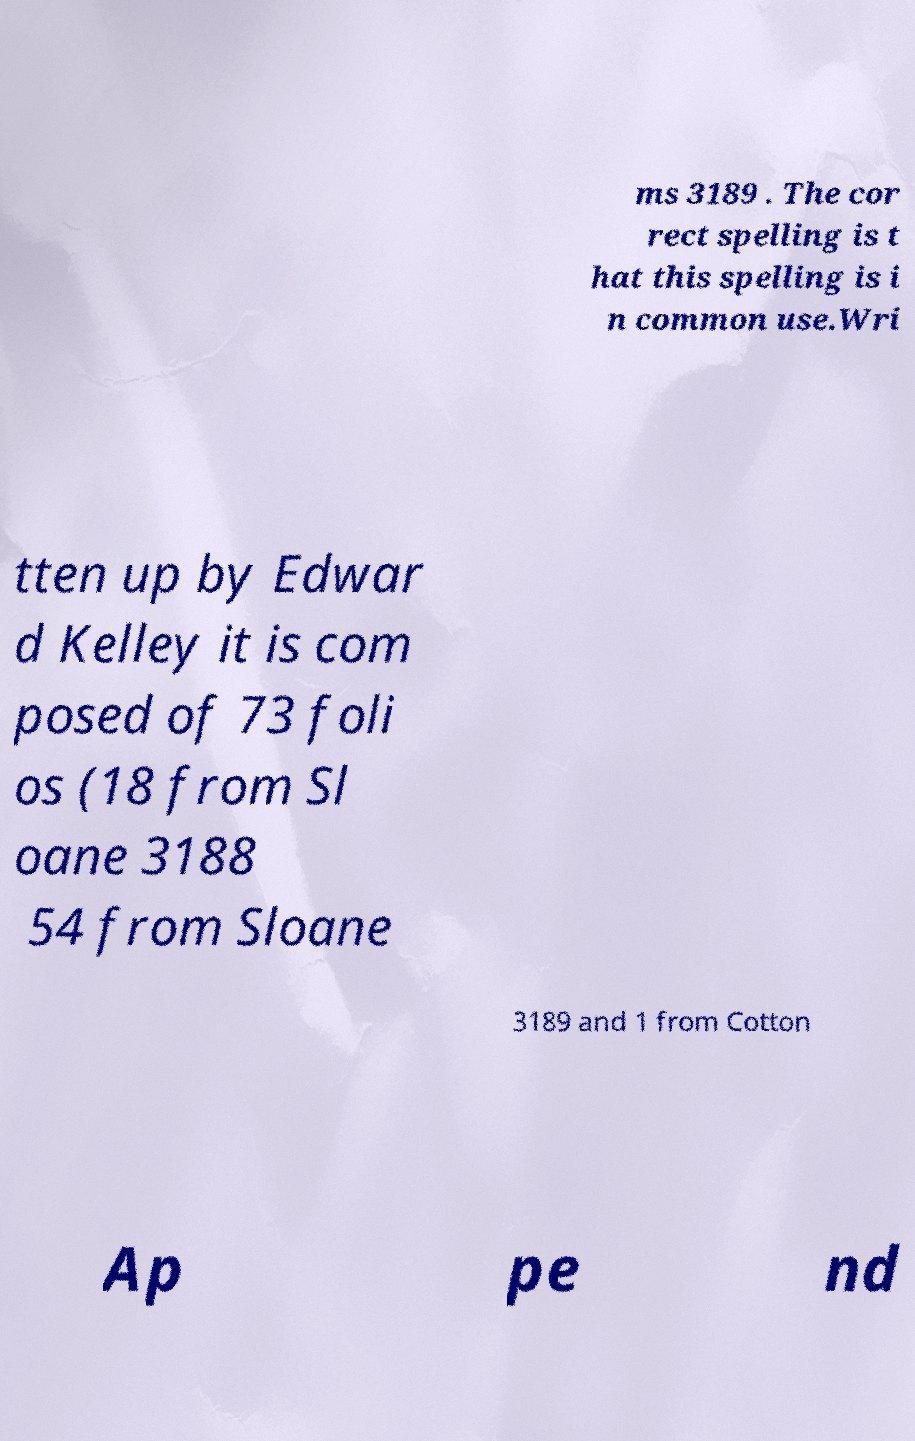Can you read and provide the text displayed in the image?This photo seems to have some interesting text. Can you extract and type it out for me? ms 3189 . The cor rect spelling is t hat this spelling is i n common use.Wri tten up by Edwar d Kelley it is com posed of 73 foli os (18 from Sl oane 3188 54 from Sloane 3189 and 1 from Cotton Ap pe nd 